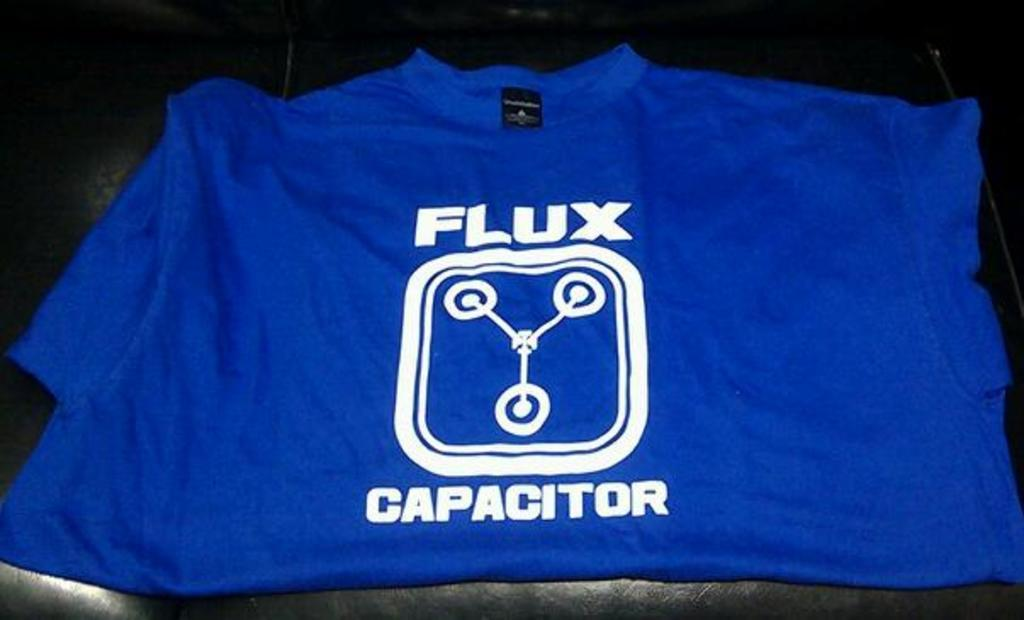Provide a one-sentence caption for the provided image. A blue shirt that says, "Flux Capacitor" in white writing is folded. 